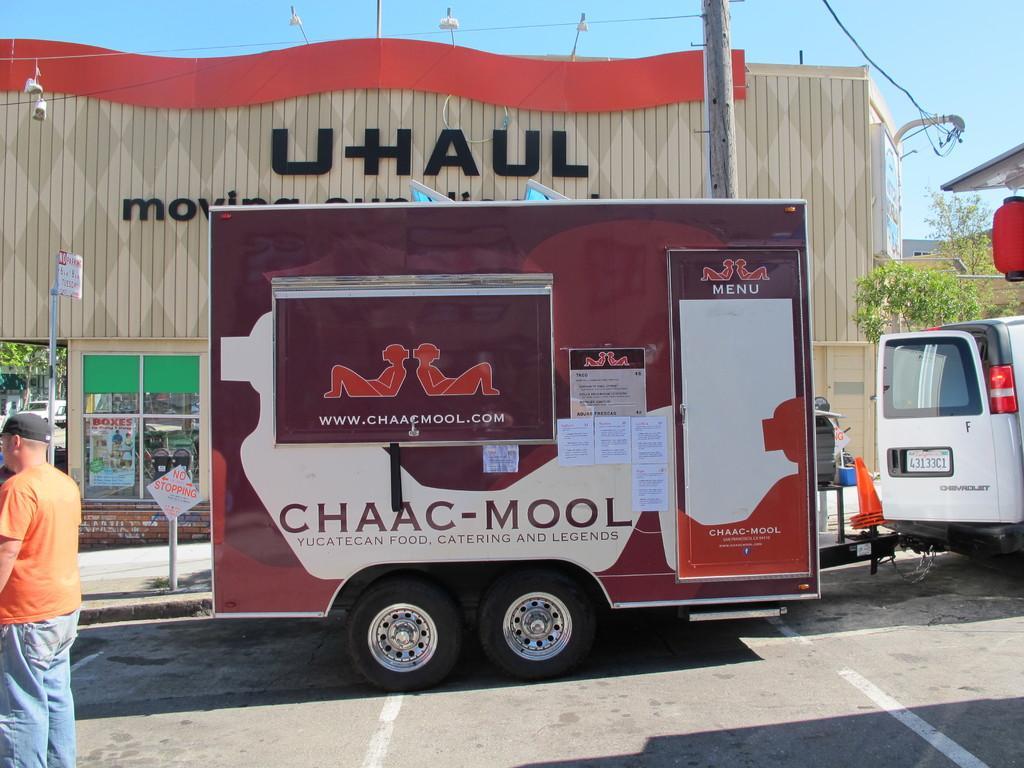How would you summarize this image in a sentence or two? In this image we can see sky, building, electric lights, poles, trees, motor vehicles on the road, sign boards, traffic cones and a person standing on the road. 